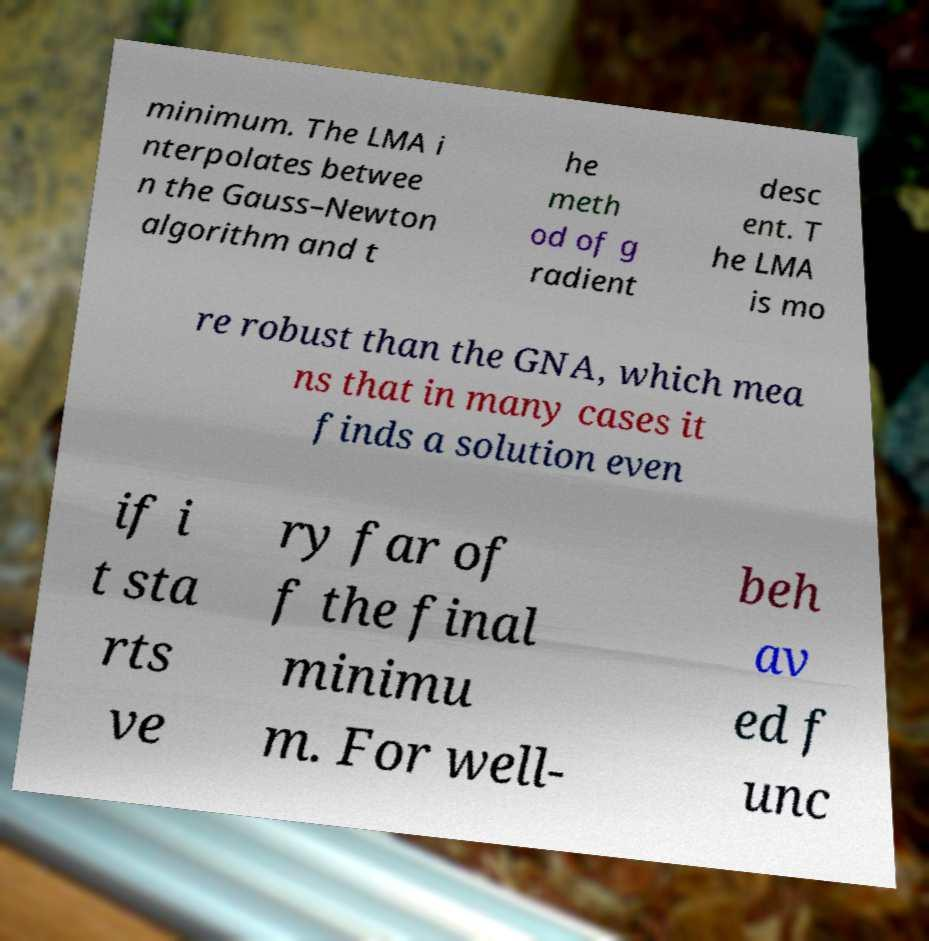Could you extract and type out the text from this image? minimum. The LMA i nterpolates betwee n the Gauss–Newton algorithm and t he meth od of g radient desc ent. T he LMA is mo re robust than the GNA, which mea ns that in many cases it finds a solution even if i t sta rts ve ry far of f the final minimu m. For well- beh av ed f unc 